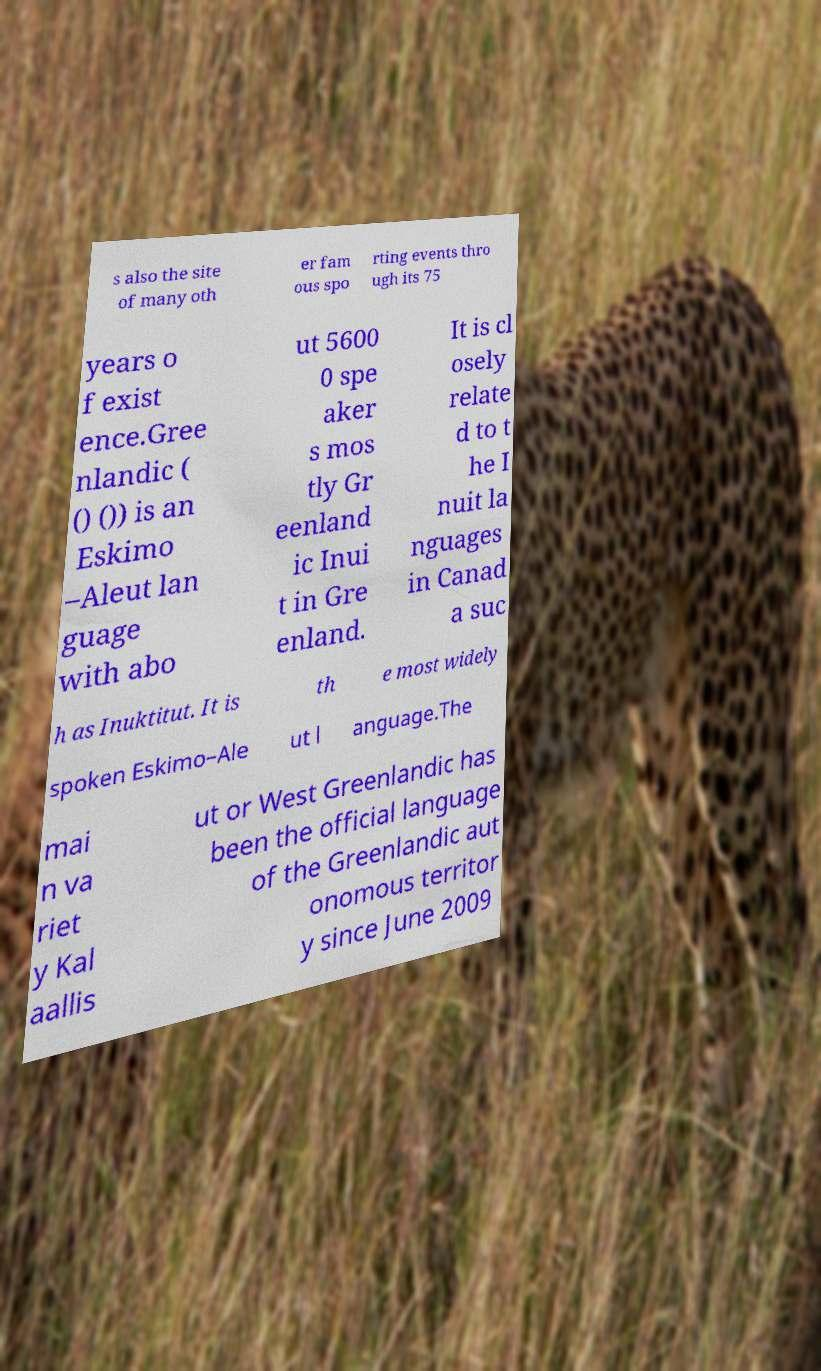For documentation purposes, I need the text within this image transcribed. Could you provide that? s also the site of many oth er fam ous spo rting events thro ugh its 75 years o f exist ence.Gree nlandic ( () ()) is an Eskimo –Aleut lan guage with abo ut 5600 0 spe aker s mos tly Gr eenland ic Inui t in Gre enland. It is cl osely relate d to t he I nuit la nguages in Canad a suc h as Inuktitut. It is th e most widely spoken Eskimo–Ale ut l anguage.The mai n va riet y Kal aallis ut or West Greenlandic has been the official language of the Greenlandic aut onomous territor y since June 2009 